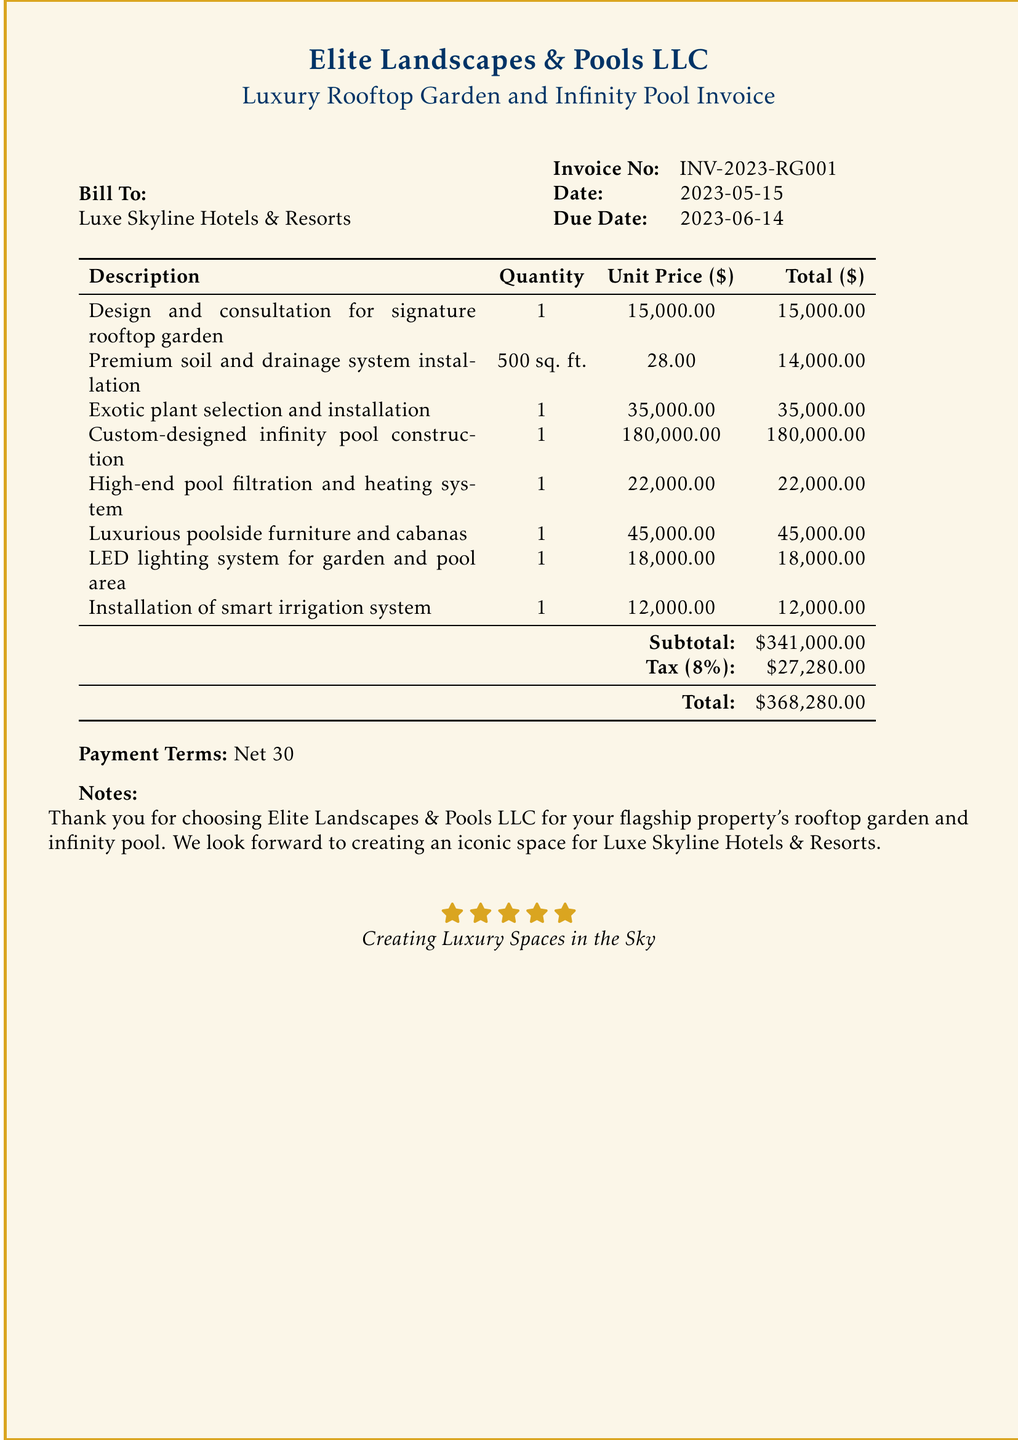What is the invoice number? The invoice number is a unique identifier for this bill found in the document.
Answer: INV-2023-RG001 What is the total amount due? The total amount due is clearly stated at the bottom of the invoice.
Answer: $368,280.00 Who is the bill addressed to? The "Bill To" section specifies the recipient of the invoice, which is Luxe Skyline Hotels & Resorts.
Answer: Luxe Skyline Hotels & Resorts How much was charged for the custom-designed infinity pool? The total for the custom-designed infinity pool is specified in the itemized list of services.
Answer: $180,000.00 What is the tax rate applied on the subtotal? The tax rate can be inferred from the tax amount calculated on the subtotal in the document.
Answer: 8% What was the quantity of premium soil and drainage system installed? The quantity of soil and drainage system is listed in the description table.
Answer: 500 sq. ft What is the effective date of the invoice? The effective date of the invoice is stated next to "Date" in the invoice header.
Answer: 2023-05-15 What is the payment term indicated? The payment term details how long the bill recipient has to pay the invoice, which is stated in the document.
Answer: Net 30 What note is included for the client? A personal note to the client is provided at the end of the invoice showing appreciation for their business.
Answer: Thank you for choosing Elite Landscapes & Pools LLC for your flagship property's rooftop garden and infinity pool 